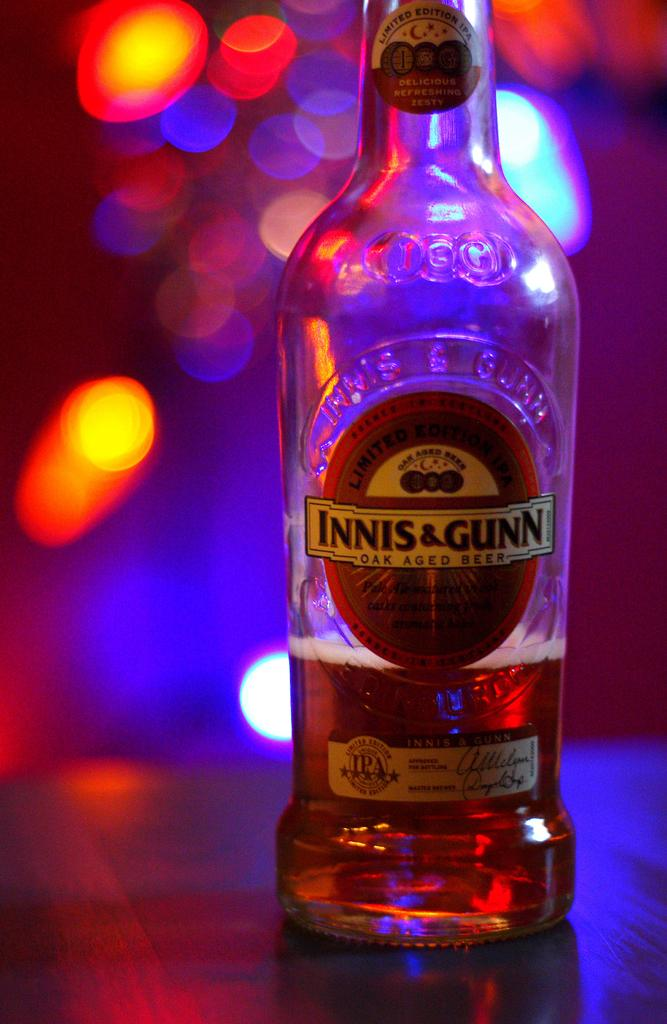<image>
Share a concise interpretation of the image provided. A bottle of beer called Innis & Gunn is sitting on a table 